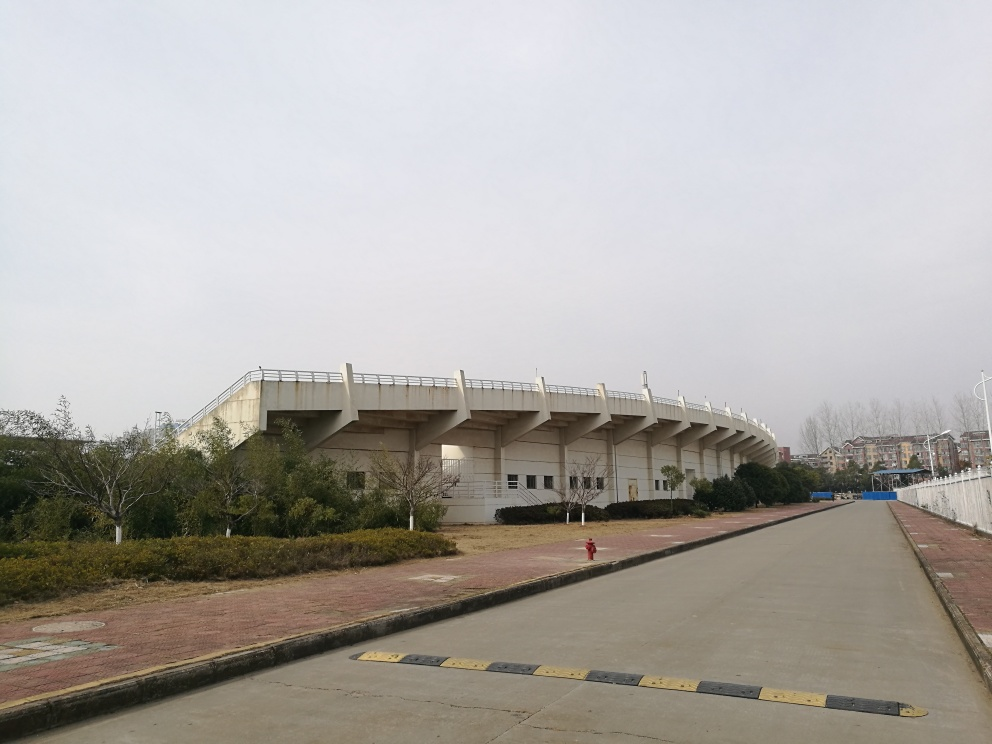How would you describe the color tone of the image? A. Vibrant and diverse B. Colorful C. Relatively monotonous D. Bland Answer with the option's letter from the given choices directly. The color tone of the image can most suitably be described as relatively monotonous (Option C). The photo displays a muted palette of colors, with the dominant hues being the grays of the architecture, the soft greens of the foliage, and the dull overcast sky. There is little vibrant, contrasting color, resulting in a subdued and homogeneous appearance. 